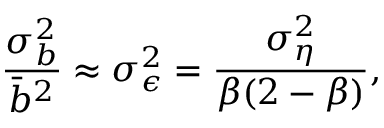Convert formula to latex. <formula><loc_0><loc_0><loc_500><loc_500>\frac { \sigma _ { b } ^ { 2 } } { \bar { b } ^ { 2 } } \approx \sigma _ { \epsilon } ^ { 2 } = \frac { \sigma _ { \eta } ^ { 2 } } { \beta ( 2 - \beta ) } ,</formula> 